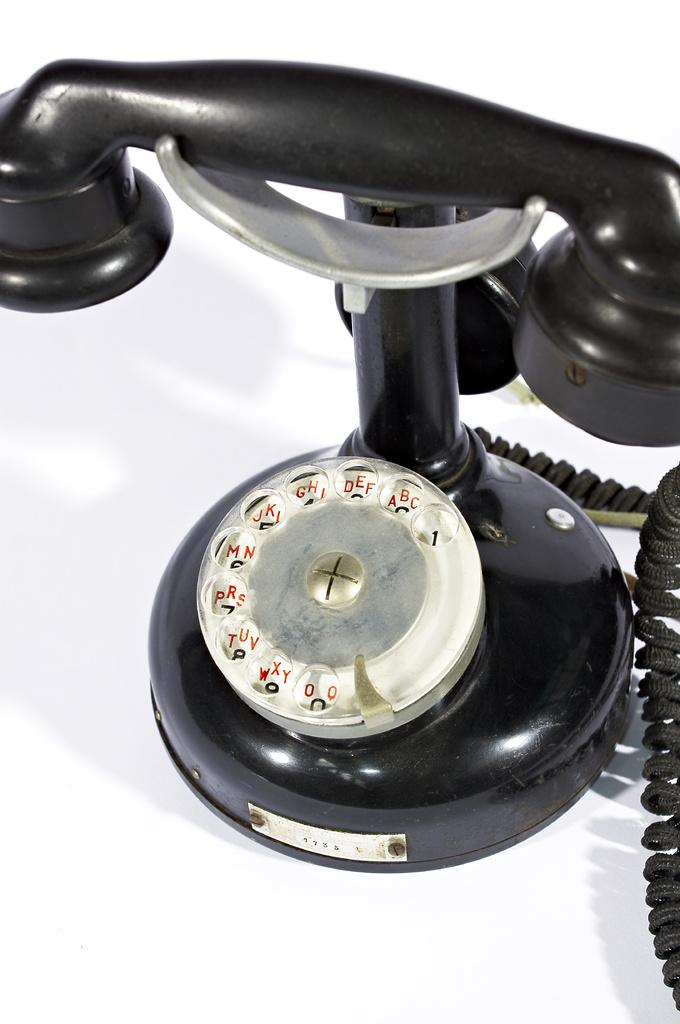What type of telephone is in the image? There is a black color telephone in the image. What is the color of the object on which the telephone is placed? The telephone is placed on a white color object. Can you see the telephone shaking in the image? No, the telephone is not shaking in the image. Is there any oil visible on the telephone or the white color object? No, there is no oil visible on the telephone or the white color object in the image. 